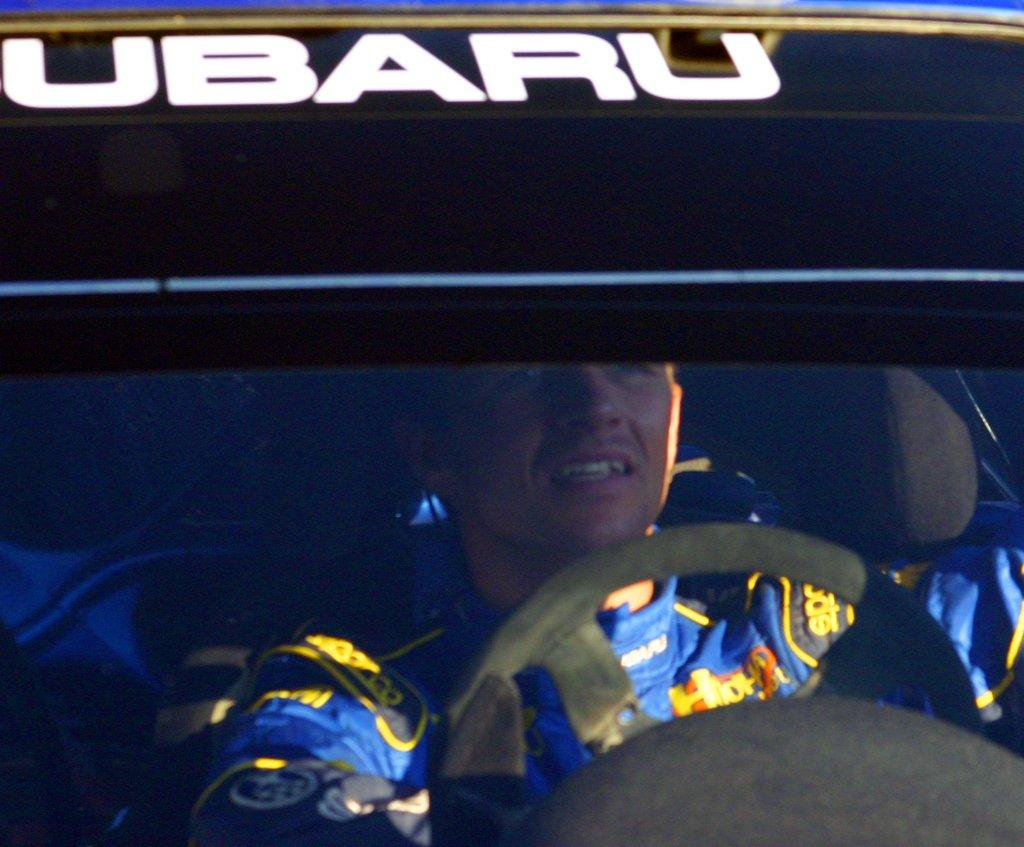Who is present in the image? There is a man in the image. What is the man doing in the image? The man is seated in a car. What type of spark can be seen coming from the scarecrow in the image? There is no scarecrow present in the image, and therefore no sparks can be seen. 